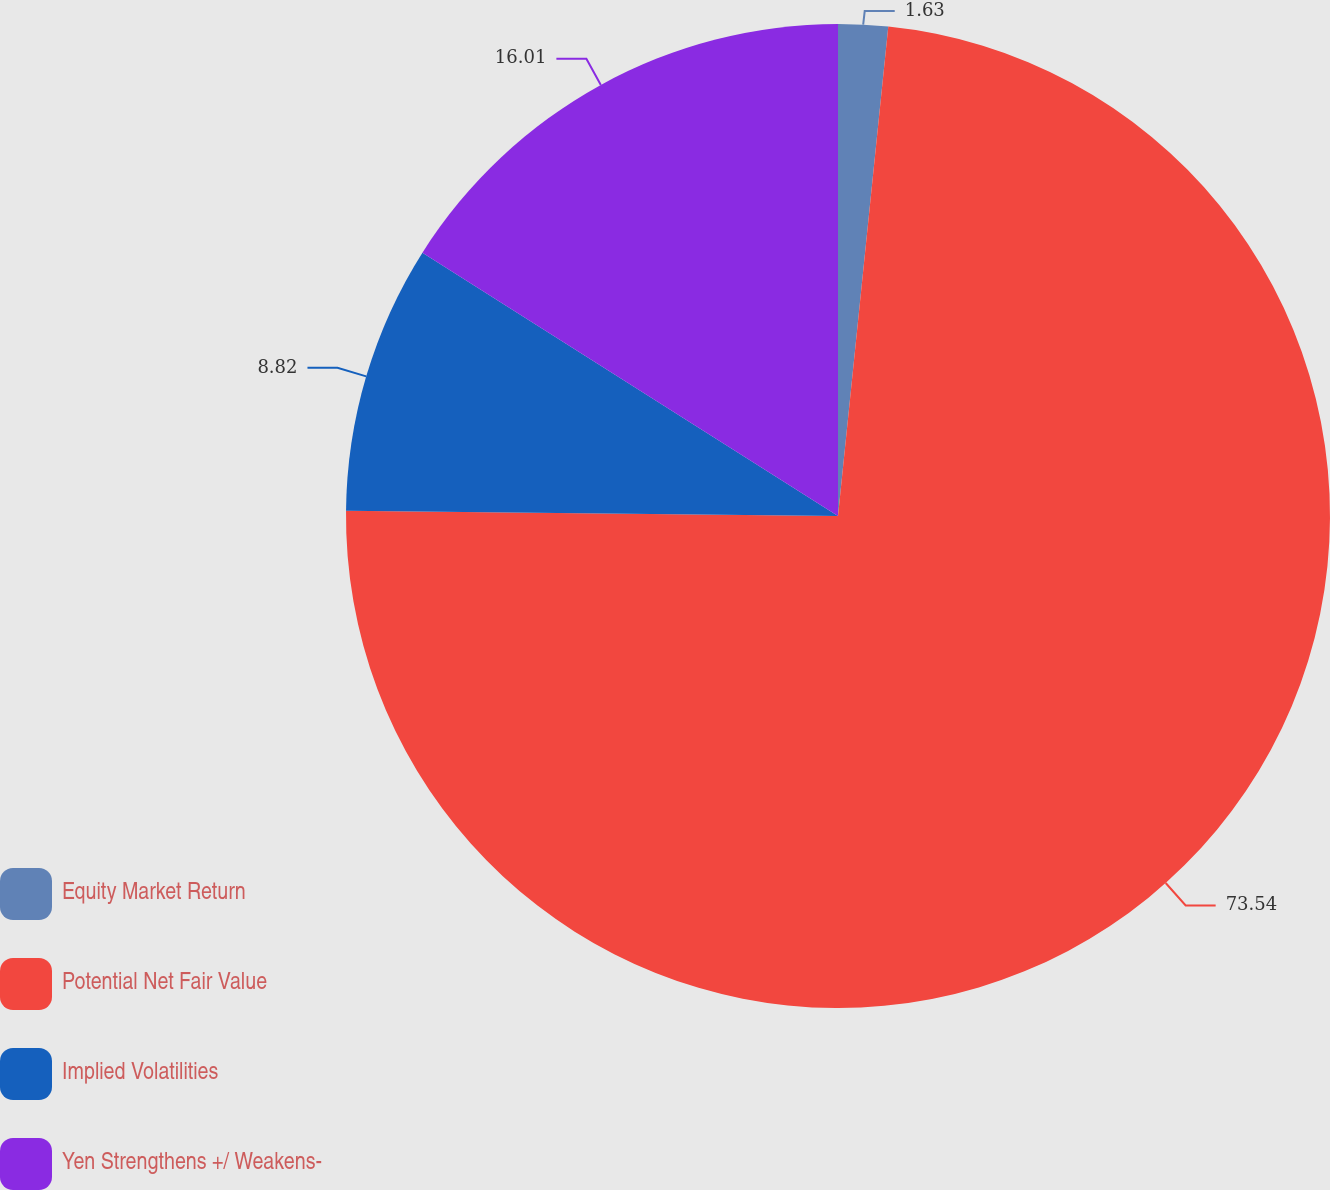Convert chart to OTSL. <chart><loc_0><loc_0><loc_500><loc_500><pie_chart><fcel>Equity Market Return<fcel>Potential Net Fair Value<fcel>Implied Volatilities<fcel>Yen Strengthens +/ Weakens-<nl><fcel>1.63%<fcel>73.54%<fcel>8.82%<fcel>16.01%<nl></chart> 